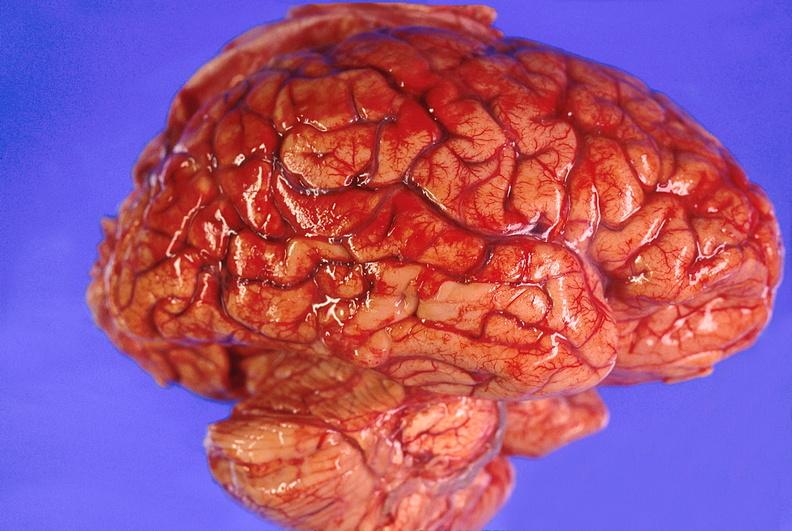what does this image show?
Answer the question using a single word or phrase. Brain abscess 